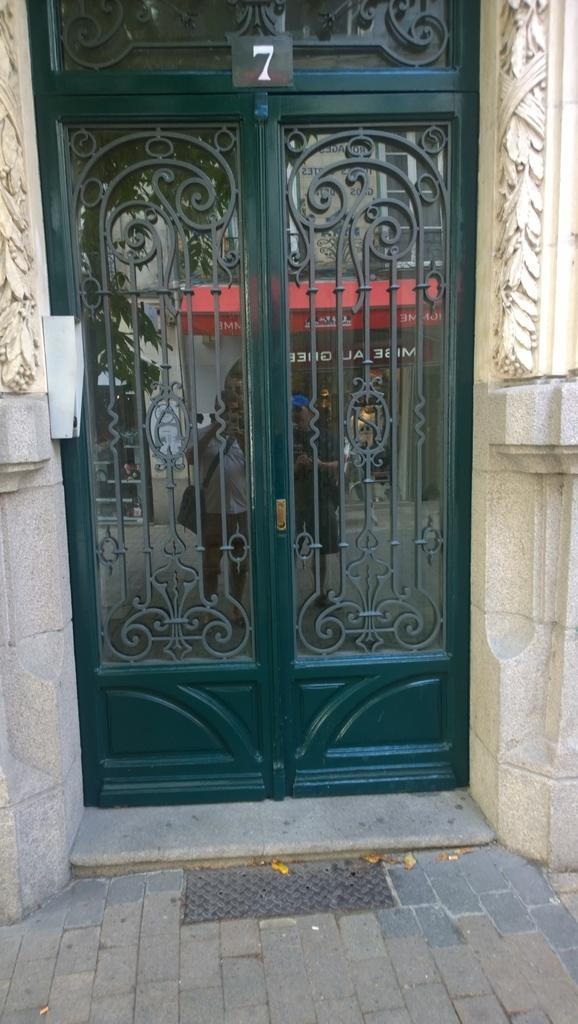What type of door is visible in the image? There is a glass door in the image. What other structures can be seen in the image? There are walls and a board visible in the image. What can be observed on the glass door? People are reflected on the glass door. How many boards are present in the image? There are boards visible in the image. What type of vegetation is present in the image? Leaves are present in the image. What type of letters are being written on the sidewalk in the image? There is no sidewalk present in the image, and therefore no letters being written on it. What type of sticks are being used to draw on the board in the image? There are no sticks visible in the image, and no drawing activity is taking place on the board. 